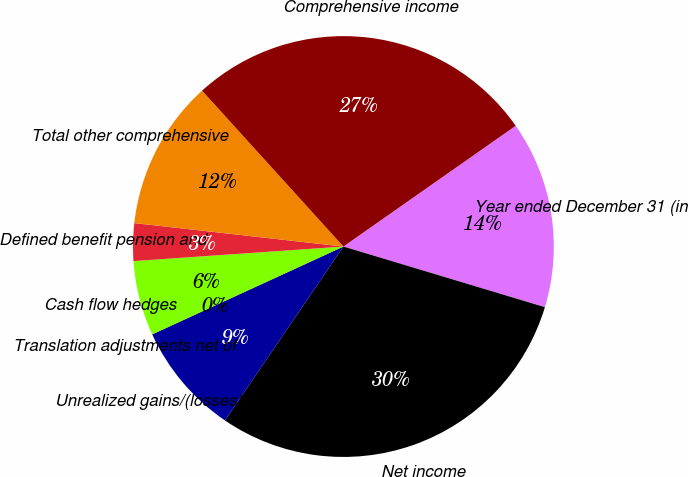Convert chart to OTSL. <chart><loc_0><loc_0><loc_500><loc_500><pie_chart><fcel>Year ended December 31 (in<fcel>Net income<fcel>Unrealized gains/(losses) on<fcel>Translation adjustments net of<fcel>Cash flow hedges<fcel>Defined benefit pension and<fcel>Total other comprehensive<fcel>Comprehensive income<nl><fcel>14.38%<fcel>29.86%<fcel>8.63%<fcel>0.0%<fcel>5.75%<fcel>2.88%<fcel>11.5%<fcel>26.99%<nl></chart> 